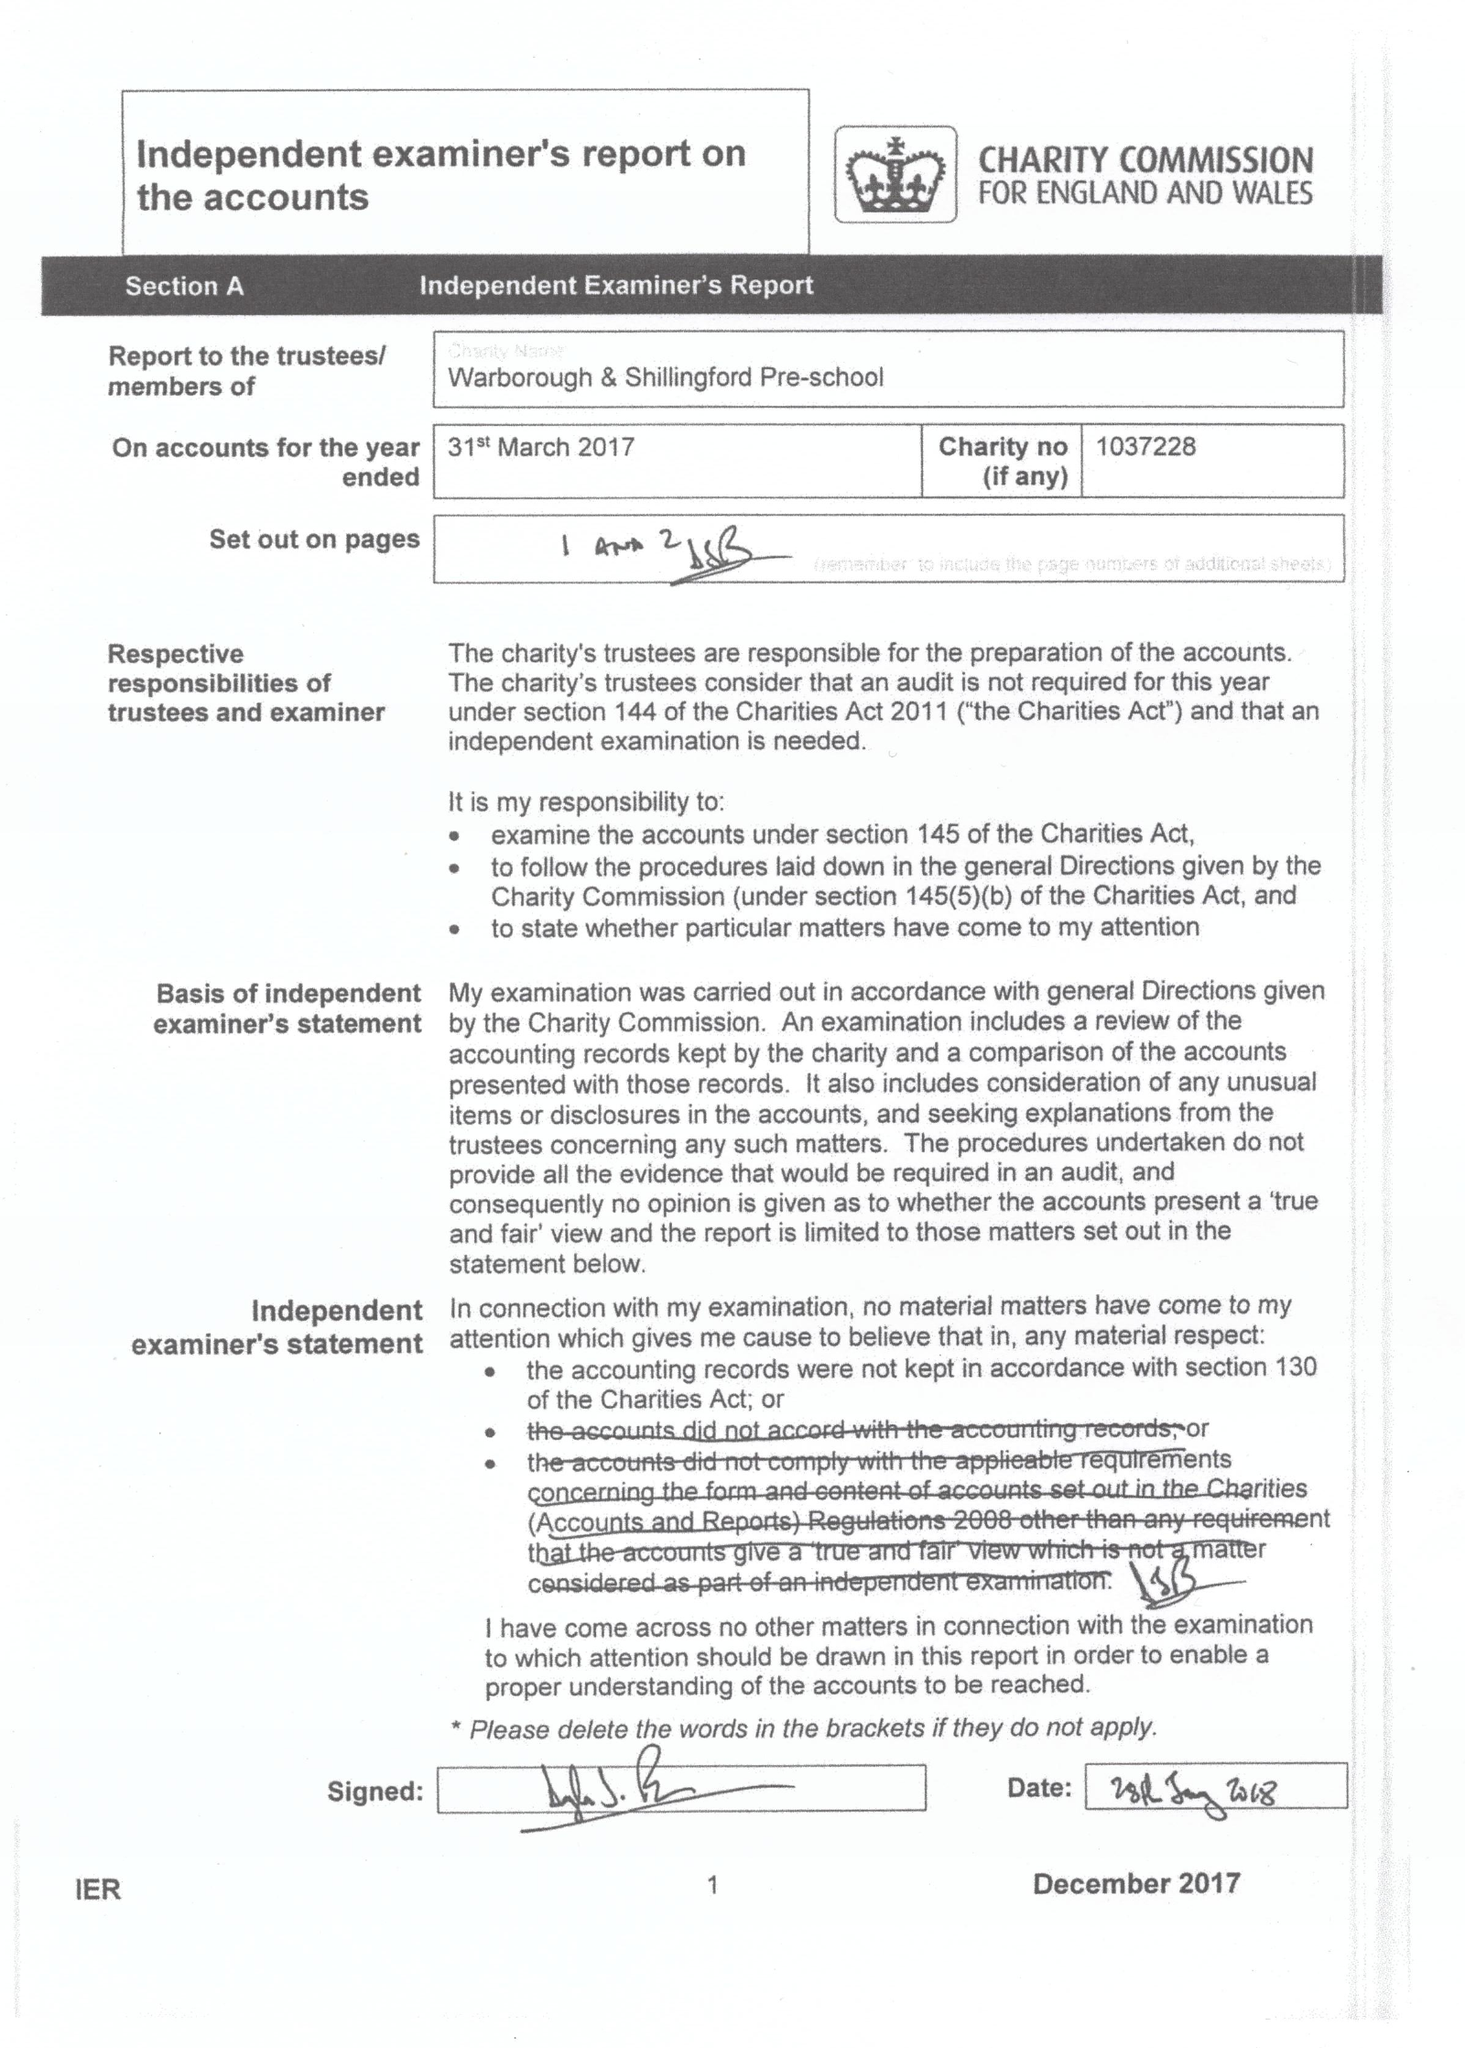What is the value for the charity_number?
Answer the question using a single word or phrase. 1037228 